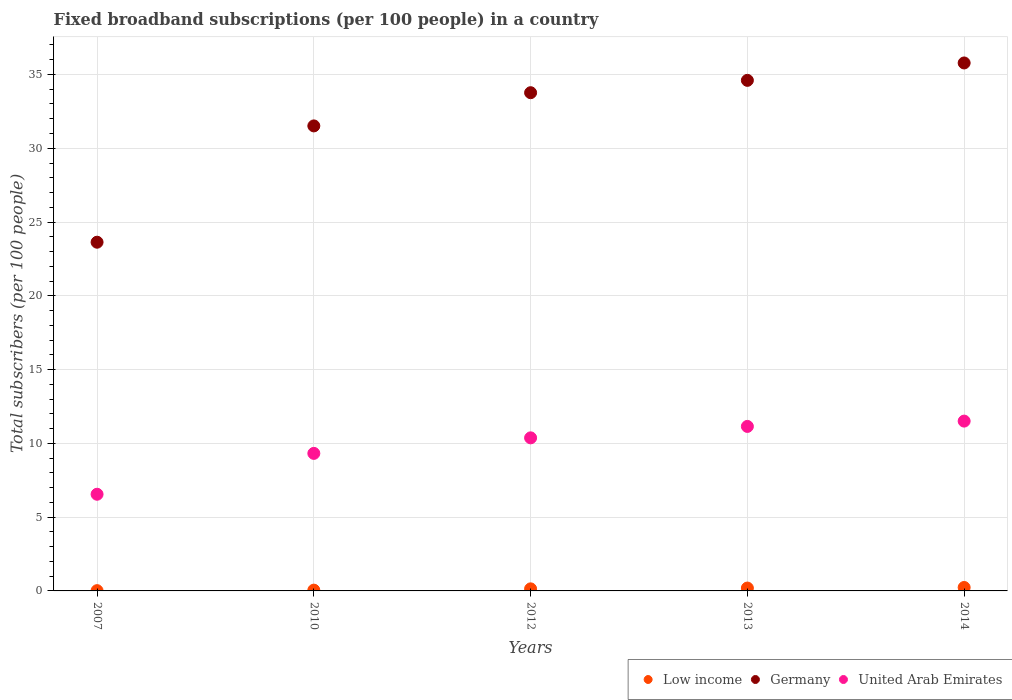How many different coloured dotlines are there?
Offer a terse response. 3. What is the number of broadband subscriptions in Low income in 2007?
Offer a very short reply. 0.02. Across all years, what is the maximum number of broadband subscriptions in Germany?
Make the answer very short. 35.78. Across all years, what is the minimum number of broadband subscriptions in Low income?
Ensure brevity in your answer.  0.02. What is the total number of broadband subscriptions in Germany in the graph?
Offer a very short reply. 159.29. What is the difference between the number of broadband subscriptions in Germany in 2007 and that in 2014?
Make the answer very short. -12.15. What is the difference between the number of broadband subscriptions in Germany in 2013 and the number of broadband subscriptions in Low income in 2012?
Keep it short and to the point. 34.46. What is the average number of broadband subscriptions in Low income per year?
Give a very brief answer. 0.13. In the year 2010, what is the difference between the number of broadband subscriptions in United Arab Emirates and number of broadband subscriptions in Low income?
Provide a succinct answer. 9.27. In how many years, is the number of broadband subscriptions in United Arab Emirates greater than 24?
Your answer should be very brief. 0. What is the ratio of the number of broadband subscriptions in Germany in 2007 to that in 2014?
Provide a succinct answer. 0.66. Is the difference between the number of broadband subscriptions in United Arab Emirates in 2012 and 2013 greater than the difference between the number of broadband subscriptions in Low income in 2012 and 2013?
Give a very brief answer. No. What is the difference between the highest and the second highest number of broadband subscriptions in Germany?
Your answer should be very brief. 1.18. What is the difference between the highest and the lowest number of broadband subscriptions in Low income?
Offer a terse response. 0.21. Is the sum of the number of broadband subscriptions in United Arab Emirates in 2007 and 2014 greater than the maximum number of broadband subscriptions in Low income across all years?
Give a very brief answer. Yes. Is the number of broadband subscriptions in Germany strictly greater than the number of broadband subscriptions in Low income over the years?
Your answer should be very brief. Yes. Is the number of broadband subscriptions in Germany strictly less than the number of broadband subscriptions in United Arab Emirates over the years?
Your answer should be compact. No. How many dotlines are there?
Provide a succinct answer. 3. How many years are there in the graph?
Provide a succinct answer. 5. Does the graph contain any zero values?
Ensure brevity in your answer.  No. Does the graph contain grids?
Offer a very short reply. Yes. Where does the legend appear in the graph?
Ensure brevity in your answer.  Bottom right. How many legend labels are there?
Offer a terse response. 3. What is the title of the graph?
Your response must be concise. Fixed broadband subscriptions (per 100 people) in a country. What is the label or title of the Y-axis?
Your answer should be compact. Total subscribers (per 100 people). What is the Total subscribers (per 100 people) in Low income in 2007?
Make the answer very short. 0.02. What is the Total subscribers (per 100 people) of Germany in 2007?
Ensure brevity in your answer.  23.63. What is the Total subscribers (per 100 people) of United Arab Emirates in 2007?
Your response must be concise. 6.55. What is the Total subscribers (per 100 people) of Low income in 2010?
Your response must be concise. 0.05. What is the Total subscribers (per 100 people) of Germany in 2010?
Your answer should be compact. 31.51. What is the Total subscribers (per 100 people) of United Arab Emirates in 2010?
Ensure brevity in your answer.  9.32. What is the Total subscribers (per 100 people) of Low income in 2012?
Your answer should be very brief. 0.14. What is the Total subscribers (per 100 people) in Germany in 2012?
Provide a short and direct response. 33.76. What is the Total subscribers (per 100 people) in United Arab Emirates in 2012?
Provide a short and direct response. 10.37. What is the Total subscribers (per 100 people) of Low income in 2013?
Your answer should be very brief. 0.19. What is the Total subscribers (per 100 people) in Germany in 2013?
Provide a short and direct response. 34.6. What is the Total subscribers (per 100 people) in United Arab Emirates in 2013?
Your answer should be very brief. 11.15. What is the Total subscribers (per 100 people) of Low income in 2014?
Provide a short and direct response. 0.23. What is the Total subscribers (per 100 people) of Germany in 2014?
Your response must be concise. 35.78. What is the Total subscribers (per 100 people) of United Arab Emirates in 2014?
Give a very brief answer. 11.51. Across all years, what is the maximum Total subscribers (per 100 people) of Low income?
Ensure brevity in your answer.  0.23. Across all years, what is the maximum Total subscribers (per 100 people) of Germany?
Keep it short and to the point. 35.78. Across all years, what is the maximum Total subscribers (per 100 people) in United Arab Emirates?
Your response must be concise. 11.51. Across all years, what is the minimum Total subscribers (per 100 people) in Low income?
Ensure brevity in your answer.  0.02. Across all years, what is the minimum Total subscribers (per 100 people) of Germany?
Make the answer very short. 23.63. Across all years, what is the minimum Total subscribers (per 100 people) in United Arab Emirates?
Your answer should be compact. 6.55. What is the total Total subscribers (per 100 people) in Low income in the graph?
Make the answer very short. 0.64. What is the total Total subscribers (per 100 people) in Germany in the graph?
Your answer should be compact. 159.29. What is the total Total subscribers (per 100 people) in United Arab Emirates in the graph?
Offer a very short reply. 48.9. What is the difference between the Total subscribers (per 100 people) in Low income in 2007 and that in 2010?
Provide a succinct answer. -0.04. What is the difference between the Total subscribers (per 100 people) in Germany in 2007 and that in 2010?
Give a very brief answer. -7.88. What is the difference between the Total subscribers (per 100 people) of United Arab Emirates in 2007 and that in 2010?
Provide a short and direct response. -2.77. What is the difference between the Total subscribers (per 100 people) of Low income in 2007 and that in 2012?
Make the answer very short. -0.12. What is the difference between the Total subscribers (per 100 people) in Germany in 2007 and that in 2012?
Ensure brevity in your answer.  -10.13. What is the difference between the Total subscribers (per 100 people) in United Arab Emirates in 2007 and that in 2012?
Your answer should be compact. -3.82. What is the difference between the Total subscribers (per 100 people) of Low income in 2007 and that in 2013?
Offer a very short reply. -0.18. What is the difference between the Total subscribers (per 100 people) of Germany in 2007 and that in 2013?
Your answer should be compact. -10.97. What is the difference between the Total subscribers (per 100 people) in United Arab Emirates in 2007 and that in 2013?
Your response must be concise. -4.6. What is the difference between the Total subscribers (per 100 people) of Low income in 2007 and that in 2014?
Make the answer very short. -0.21. What is the difference between the Total subscribers (per 100 people) in Germany in 2007 and that in 2014?
Your answer should be very brief. -12.15. What is the difference between the Total subscribers (per 100 people) in United Arab Emirates in 2007 and that in 2014?
Your answer should be compact. -4.96. What is the difference between the Total subscribers (per 100 people) of Low income in 2010 and that in 2012?
Give a very brief answer. -0.09. What is the difference between the Total subscribers (per 100 people) of Germany in 2010 and that in 2012?
Ensure brevity in your answer.  -2.25. What is the difference between the Total subscribers (per 100 people) of United Arab Emirates in 2010 and that in 2012?
Your answer should be very brief. -1.05. What is the difference between the Total subscribers (per 100 people) of Low income in 2010 and that in 2013?
Your answer should be compact. -0.14. What is the difference between the Total subscribers (per 100 people) in Germany in 2010 and that in 2013?
Ensure brevity in your answer.  -3.09. What is the difference between the Total subscribers (per 100 people) in United Arab Emirates in 2010 and that in 2013?
Your answer should be very brief. -1.83. What is the difference between the Total subscribers (per 100 people) in Low income in 2010 and that in 2014?
Offer a terse response. -0.18. What is the difference between the Total subscribers (per 100 people) of Germany in 2010 and that in 2014?
Make the answer very short. -4.27. What is the difference between the Total subscribers (per 100 people) of United Arab Emirates in 2010 and that in 2014?
Make the answer very short. -2.19. What is the difference between the Total subscribers (per 100 people) in Low income in 2012 and that in 2013?
Make the answer very short. -0.05. What is the difference between the Total subscribers (per 100 people) in Germany in 2012 and that in 2013?
Keep it short and to the point. -0.84. What is the difference between the Total subscribers (per 100 people) in United Arab Emirates in 2012 and that in 2013?
Offer a terse response. -0.77. What is the difference between the Total subscribers (per 100 people) in Low income in 2012 and that in 2014?
Your answer should be very brief. -0.09. What is the difference between the Total subscribers (per 100 people) in Germany in 2012 and that in 2014?
Offer a very short reply. -2.02. What is the difference between the Total subscribers (per 100 people) of United Arab Emirates in 2012 and that in 2014?
Provide a succinct answer. -1.13. What is the difference between the Total subscribers (per 100 people) in Low income in 2013 and that in 2014?
Your answer should be very brief. -0.04. What is the difference between the Total subscribers (per 100 people) in Germany in 2013 and that in 2014?
Make the answer very short. -1.18. What is the difference between the Total subscribers (per 100 people) in United Arab Emirates in 2013 and that in 2014?
Keep it short and to the point. -0.36. What is the difference between the Total subscribers (per 100 people) of Low income in 2007 and the Total subscribers (per 100 people) of Germany in 2010?
Offer a very short reply. -31.5. What is the difference between the Total subscribers (per 100 people) in Low income in 2007 and the Total subscribers (per 100 people) in United Arab Emirates in 2010?
Your response must be concise. -9.3. What is the difference between the Total subscribers (per 100 people) in Germany in 2007 and the Total subscribers (per 100 people) in United Arab Emirates in 2010?
Keep it short and to the point. 14.31. What is the difference between the Total subscribers (per 100 people) of Low income in 2007 and the Total subscribers (per 100 people) of Germany in 2012?
Your answer should be very brief. -33.75. What is the difference between the Total subscribers (per 100 people) of Low income in 2007 and the Total subscribers (per 100 people) of United Arab Emirates in 2012?
Offer a very short reply. -10.36. What is the difference between the Total subscribers (per 100 people) of Germany in 2007 and the Total subscribers (per 100 people) of United Arab Emirates in 2012?
Offer a terse response. 13.26. What is the difference between the Total subscribers (per 100 people) in Low income in 2007 and the Total subscribers (per 100 people) in Germany in 2013?
Keep it short and to the point. -34.58. What is the difference between the Total subscribers (per 100 people) in Low income in 2007 and the Total subscribers (per 100 people) in United Arab Emirates in 2013?
Offer a very short reply. -11.13. What is the difference between the Total subscribers (per 100 people) in Germany in 2007 and the Total subscribers (per 100 people) in United Arab Emirates in 2013?
Make the answer very short. 12.48. What is the difference between the Total subscribers (per 100 people) of Low income in 2007 and the Total subscribers (per 100 people) of Germany in 2014?
Your response must be concise. -35.76. What is the difference between the Total subscribers (per 100 people) of Low income in 2007 and the Total subscribers (per 100 people) of United Arab Emirates in 2014?
Your answer should be compact. -11.49. What is the difference between the Total subscribers (per 100 people) in Germany in 2007 and the Total subscribers (per 100 people) in United Arab Emirates in 2014?
Offer a terse response. 12.12. What is the difference between the Total subscribers (per 100 people) of Low income in 2010 and the Total subscribers (per 100 people) of Germany in 2012?
Provide a succinct answer. -33.71. What is the difference between the Total subscribers (per 100 people) of Low income in 2010 and the Total subscribers (per 100 people) of United Arab Emirates in 2012?
Your response must be concise. -10.32. What is the difference between the Total subscribers (per 100 people) in Germany in 2010 and the Total subscribers (per 100 people) in United Arab Emirates in 2012?
Offer a terse response. 21.14. What is the difference between the Total subscribers (per 100 people) in Low income in 2010 and the Total subscribers (per 100 people) in Germany in 2013?
Your response must be concise. -34.55. What is the difference between the Total subscribers (per 100 people) of Low income in 2010 and the Total subscribers (per 100 people) of United Arab Emirates in 2013?
Your answer should be very brief. -11.09. What is the difference between the Total subscribers (per 100 people) of Germany in 2010 and the Total subscribers (per 100 people) of United Arab Emirates in 2013?
Your answer should be very brief. 20.37. What is the difference between the Total subscribers (per 100 people) of Low income in 2010 and the Total subscribers (per 100 people) of Germany in 2014?
Offer a very short reply. -35.73. What is the difference between the Total subscribers (per 100 people) in Low income in 2010 and the Total subscribers (per 100 people) in United Arab Emirates in 2014?
Make the answer very short. -11.45. What is the difference between the Total subscribers (per 100 people) of Germany in 2010 and the Total subscribers (per 100 people) of United Arab Emirates in 2014?
Offer a very short reply. 20.01. What is the difference between the Total subscribers (per 100 people) in Low income in 2012 and the Total subscribers (per 100 people) in Germany in 2013?
Make the answer very short. -34.46. What is the difference between the Total subscribers (per 100 people) in Low income in 2012 and the Total subscribers (per 100 people) in United Arab Emirates in 2013?
Make the answer very short. -11.01. What is the difference between the Total subscribers (per 100 people) in Germany in 2012 and the Total subscribers (per 100 people) in United Arab Emirates in 2013?
Your response must be concise. 22.62. What is the difference between the Total subscribers (per 100 people) in Low income in 2012 and the Total subscribers (per 100 people) in Germany in 2014?
Keep it short and to the point. -35.64. What is the difference between the Total subscribers (per 100 people) in Low income in 2012 and the Total subscribers (per 100 people) in United Arab Emirates in 2014?
Your answer should be compact. -11.37. What is the difference between the Total subscribers (per 100 people) in Germany in 2012 and the Total subscribers (per 100 people) in United Arab Emirates in 2014?
Your response must be concise. 22.26. What is the difference between the Total subscribers (per 100 people) of Low income in 2013 and the Total subscribers (per 100 people) of Germany in 2014?
Provide a succinct answer. -35.59. What is the difference between the Total subscribers (per 100 people) in Low income in 2013 and the Total subscribers (per 100 people) in United Arab Emirates in 2014?
Ensure brevity in your answer.  -11.31. What is the difference between the Total subscribers (per 100 people) of Germany in 2013 and the Total subscribers (per 100 people) of United Arab Emirates in 2014?
Ensure brevity in your answer.  23.09. What is the average Total subscribers (per 100 people) of Low income per year?
Provide a succinct answer. 0.13. What is the average Total subscribers (per 100 people) in Germany per year?
Offer a very short reply. 31.86. What is the average Total subscribers (per 100 people) of United Arab Emirates per year?
Your answer should be compact. 9.78. In the year 2007, what is the difference between the Total subscribers (per 100 people) of Low income and Total subscribers (per 100 people) of Germany?
Offer a terse response. -23.61. In the year 2007, what is the difference between the Total subscribers (per 100 people) of Low income and Total subscribers (per 100 people) of United Arab Emirates?
Give a very brief answer. -6.53. In the year 2007, what is the difference between the Total subscribers (per 100 people) of Germany and Total subscribers (per 100 people) of United Arab Emirates?
Your answer should be compact. 17.08. In the year 2010, what is the difference between the Total subscribers (per 100 people) of Low income and Total subscribers (per 100 people) of Germany?
Ensure brevity in your answer.  -31.46. In the year 2010, what is the difference between the Total subscribers (per 100 people) in Low income and Total subscribers (per 100 people) in United Arab Emirates?
Your answer should be very brief. -9.27. In the year 2010, what is the difference between the Total subscribers (per 100 people) of Germany and Total subscribers (per 100 people) of United Arab Emirates?
Your answer should be very brief. 22.19. In the year 2012, what is the difference between the Total subscribers (per 100 people) of Low income and Total subscribers (per 100 people) of Germany?
Offer a terse response. -33.62. In the year 2012, what is the difference between the Total subscribers (per 100 people) of Low income and Total subscribers (per 100 people) of United Arab Emirates?
Provide a succinct answer. -10.23. In the year 2012, what is the difference between the Total subscribers (per 100 people) in Germany and Total subscribers (per 100 people) in United Arab Emirates?
Keep it short and to the point. 23.39. In the year 2013, what is the difference between the Total subscribers (per 100 people) in Low income and Total subscribers (per 100 people) in Germany?
Your response must be concise. -34.41. In the year 2013, what is the difference between the Total subscribers (per 100 people) in Low income and Total subscribers (per 100 people) in United Arab Emirates?
Your response must be concise. -10.95. In the year 2013, what is the difference between the Total subscribers (per 100 people) of Germany and Total subscribers (per 100 people) of United Arab Emirates?
Your answer should be compact. 23.45. In the year 2014, what is the difference between the Total subscribers (per 100 people) in Low income and Total subscribers (per 100 people) in Germany?
Give a very brief answer. -35.55. In the year 2014, what is the difference between the Total subscribers (per 100 people) in Low income and Total subscribers (per 100 people) in United Arab Emirates?
Offer a very short reply. -11.28. In the year 2014, what is the difference between the Total subscribers (per 100 people) of Germany and Total subscribers (per 100 people) of United Arab Emirates?
Your answer should be very brief. 24.27. What is the ratio of the Total subscribers (per 100 people) in Low income in 2007 to that in 2010?
Offer a very short reply. 0.35. What is the ratio of the Total subscribers (per 100 people) of Germany in 2007 to that in 2010?
Provide a short and direct response. 0.75. What is the ratio of the Total subscribers (per 100 people) of United Arab Emirates in 2007 to that in 2010?
Offer a very short reply. 0.7. What is the ratio of the Total subscribers (per 100 people) in Low income in 2007 to that in 2012?
Make the answer very short. 0.13. What is the ratio of the Total subscribers (per 100 people) of Germany in 2007 to that in 2012?
Offer a terse response. 0.7. What is the ratio of the Total subscribers (per 100 people) in United Arab Emirates in 2007 to that in 2012?
Your response must be concise. 0.63. What is the ratio of the Total subscribers (per 100 people) of Low income in 2007 to that in 2013?
Provide a succinct answer. 0.1. What is the ratio of the Total subscribers (per 100 people) in Germany in 2007 to that in 2013?
Keep it short and to the point. 0.68. What is the ratio of the Total subscribers (per 100 people) in United Arab Emirates in 2007 to that in 2013?
Your answer should be compact. 0.59. What is the ratio of the Total subscribers (per 100 people) in Low income in 2007 to that in 2014?
Ensure brevity in your answer.  0.08. What is the ratio of the Total subscribers (per 100 people) in Germany in 2007 to that in 2014?
Offer a very short reply. 0.66. What is the ratio of the Total subscribers (per 100 people) in United Arab Emirates in 2007 to that in 2014?
Your response must be concise. 0.57. What is the ratio of the Total subscribers (per 100 people) of Low income in 2010 to that in 2012?
Offer a very short reply. 0.38. What is the ratio of the Total subscribers (per 100 people) in Germany in 2010 to that in 2012?
Make the answer very short. 0.93. What is the ratio of the Total subscribers (per 100 people) of United Arab Emirates in 2010 to that in 2012?
Ensure brevity in your answer.  0.9. What is the ratio of the Total subscribers (per 100 people) in Low income in 2010 to that in 2013?
Give a very brief answer. 0.28. What is the ratio of the Total subscribers (per 100 people) of Germany in 2010 to that in 2013?
Offer a terse response. 0.91. What is the ratio of the Total subscribers (per 100 people) in United Arab Emirates in 2010 to that in 2013?
Your answer should be very brief. 0.84. What is the ratio of the Total subscribers (per 100 people) of Low income in 2010 to that in 2014?
Your answer should be very brief. 0.23. What is the ratio of the Total subscribers (per 100 people) of Germany in 2010 to that in 2014?
Provide a short and direct response. 0.88. What is the ratio of the Total subscribers (per 100 people) of United Arab Emirates in 2010 to that in 2014?
Ensure brevity in your answer.  0.81. What is the ratio of the Total subscribers (per 100 people) of Low income in 2012 to that in 2013?
Offer a terse response. 0.72. What is the ratio of the Total subscribers (per 100 people) of Germany in 2012 to that in 2013?
Provide a short and direct response. 0.98. What is the ratio of the Total subscribers (per 100 people) in United Arab Emirates in 2012 to that in 2013?
Provide a succinct answer. 0.93. What is the ratio of the Total subscribers (per 100 people) in Low income in 2012 to that in 2014?
Your response must be concise. 0.6. What is the ratio of the Total subscribers (per 100 people) in Germany in 2012 to that in 2014?
Ensure brevity in your answer.  0.94. What is the ratio of the Total subscribers (per 100 people) of United Arab Emirates in 2012 to that in 2014?
Ensure brevity in your answer.  0.9. What is the ratio of the Total subscribers (per 100 people) of Low income in 2013 to that in 2014?
Give a very brief answer. 0.83. What is the ratio of the Total subscribers (per 100 people) of Germany in 2013 to that in 2014?
Provide a short and direct response. 0.97. What is the ratio of the Total subscribers (per 100 people) in United Arab Emirates in 2013 to that in 2014?
Ensure brevity in your answer.  0.97. What is the difference between the highest and the second highest Total subscribers (per 100 people) in Low income?
Your response must be concise. 0.04. What is the difference between the highest and the second highest Total subscribers (per 100 people) in Germany?
Give a very brief answer. 1.18. What is the difference between the highest and the second highest Total subscribers (per 100 people) in United Arab Emirates?
Provide a succinct answer. 0.36. What is the difference between the highest and the lowest Total subscribers (per 100 people) of Low income?
Ensure brevity in your answer.  0.21. What is the difference between the highest and the lowest Total subscribers (per 100 people) in Germany?
Ensure brevity in your answer.  12.15. What is the difference between the highest and the lowest Total subscribers (per 100 people) of United Arab Emirates?
Provide a short and direct response. 4.96. 